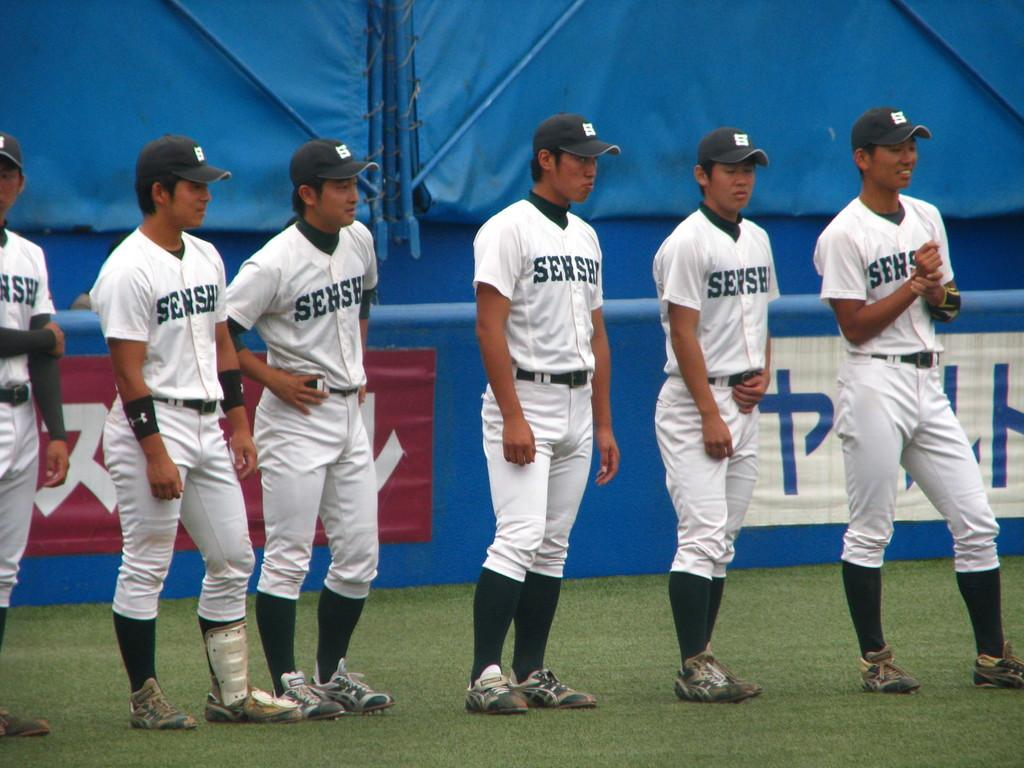Provide a one-sentence caption for the provided image. An Asian baseball team with shirts saying SENSE is lined up near the edge of the field. 